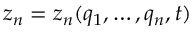Convert formula to latex. <formula><loc_0><loc_0><loc_500><loc_500>z _ { n } = z _ { n } ( q _ { 1 } , \dots , q _ { n } , t )</formula> 